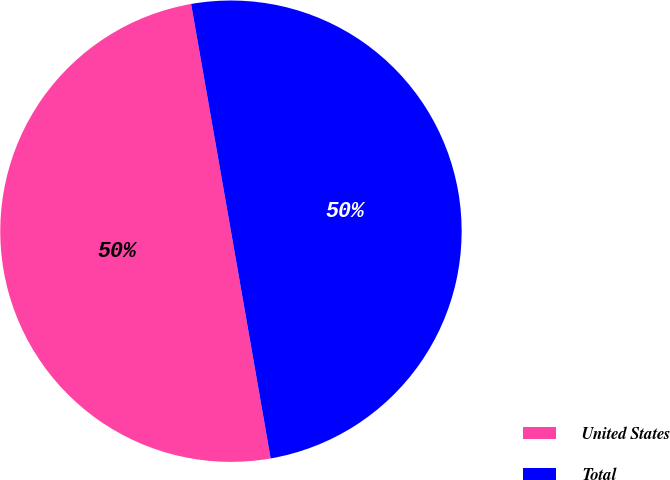Convert chart to OTSL. <chart><loc_0><loc_0><loc_500><loc_500><pie_chart><fcel>United States<fcel>Total<nl><fcel>49.99%<fcel>50.01%<nl></chart> 